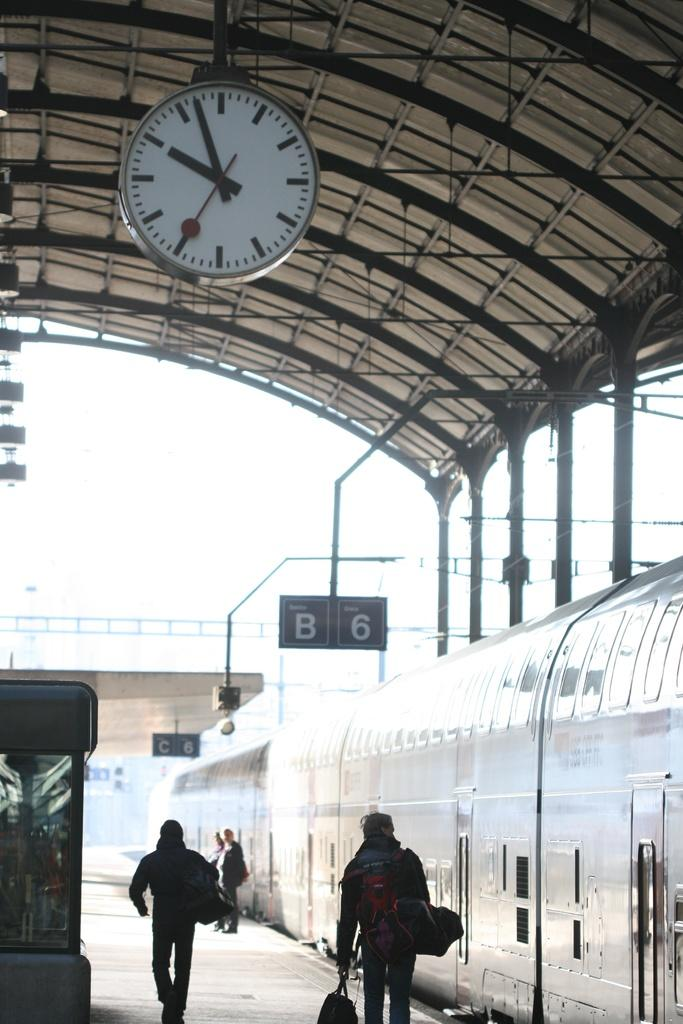<image>
Relay a brief, clear account of the picture shown. A train station clock has the time of 09:57 and a sign behind it with a B and 6. 